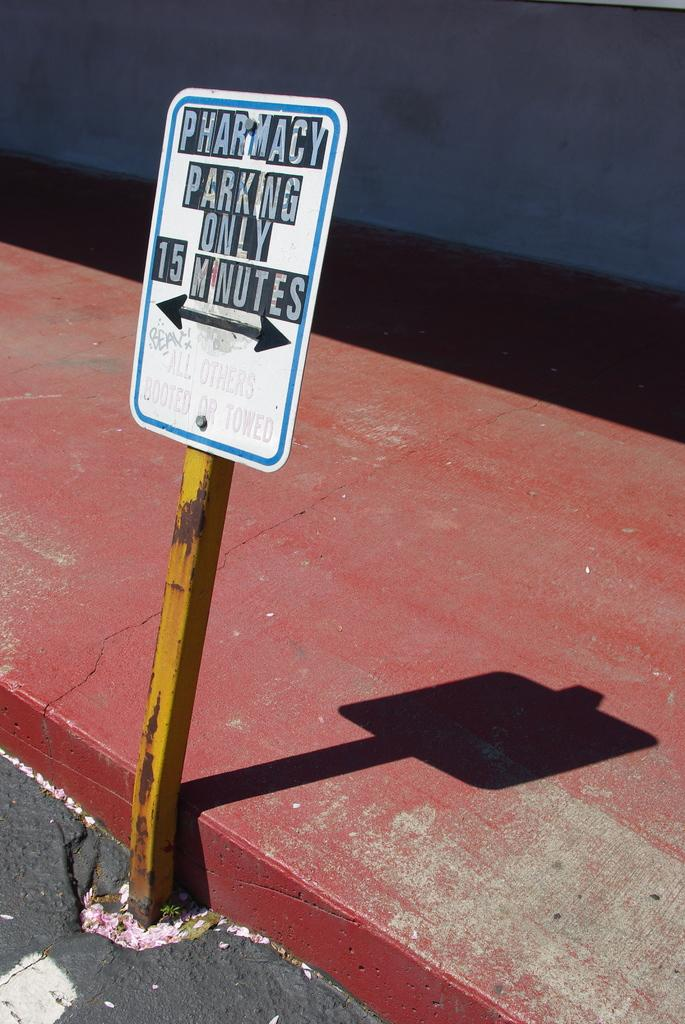<image>
Write a terse but informative summary of the picture. A sign reads "pharmacy parking only 15 minutes." 